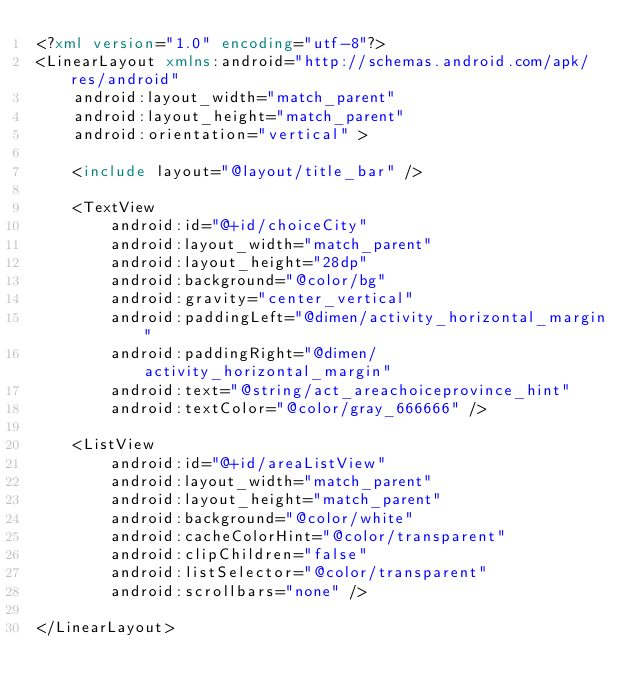<code> <loc_0><loc_0><loc_500><loc_500><_XML_><?xml version="1.0" encoding="utf-8"?>
<LinearLayout xmlns:android="http://schemas.android.com/apk/res/android"
    android:layout_width="match_parent"
    android:layout_height="match_parent"
    android:orientation="vertical" >

    <include layout="@layout/title_bar" />

    <TextView
        android:id="@+id/choiceCity"
        android:layout_width="match_parent"
        android:layout_height="28dp"
        android:background="@color/bg"
        android:gravity="center_vertical"
        android:paddingLeft="@dimen/activity_horizontal_margin"
        android:paddingRight="@dimen/activity_horizontal_margin"
        android:text="@string/act_areachoiceprovince_hint"
        android:textColor="@color/gray_666666" />

    <ListView
        android:id="@+id/areaListView"
        android:layout_width="match_parent"
        android:layout_height="match_parent"
        android:background="@color/white"
        android:cacheColorHint="@color/transparent"
        android:clipChildren="false"
        android:listSelector="@color/transparent"
        android:scrollbars="none" />

</LinearLayout></code> 